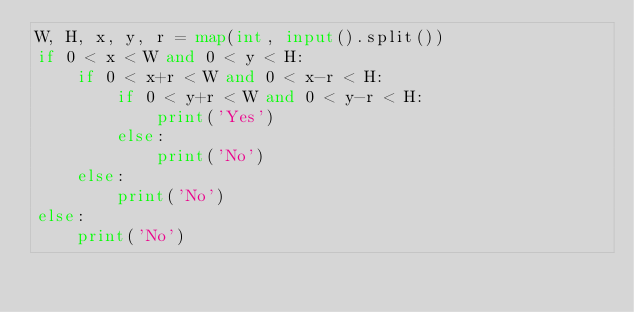Convert code to text. <code><loc_0><loc_0><loc_500><loc_500><_Python_>W, H, x, y, r = map(int, input().split())
if 0 < x < W and 0 < y < H:
    if 0 < x+r < W and 0 < x-r < H:
        if 0 < y+r < W and 0 < y-r < H:
            print('Yes')
        else:
            print('No')
    else:
        print('No')
else:
    print('No')

</code> 